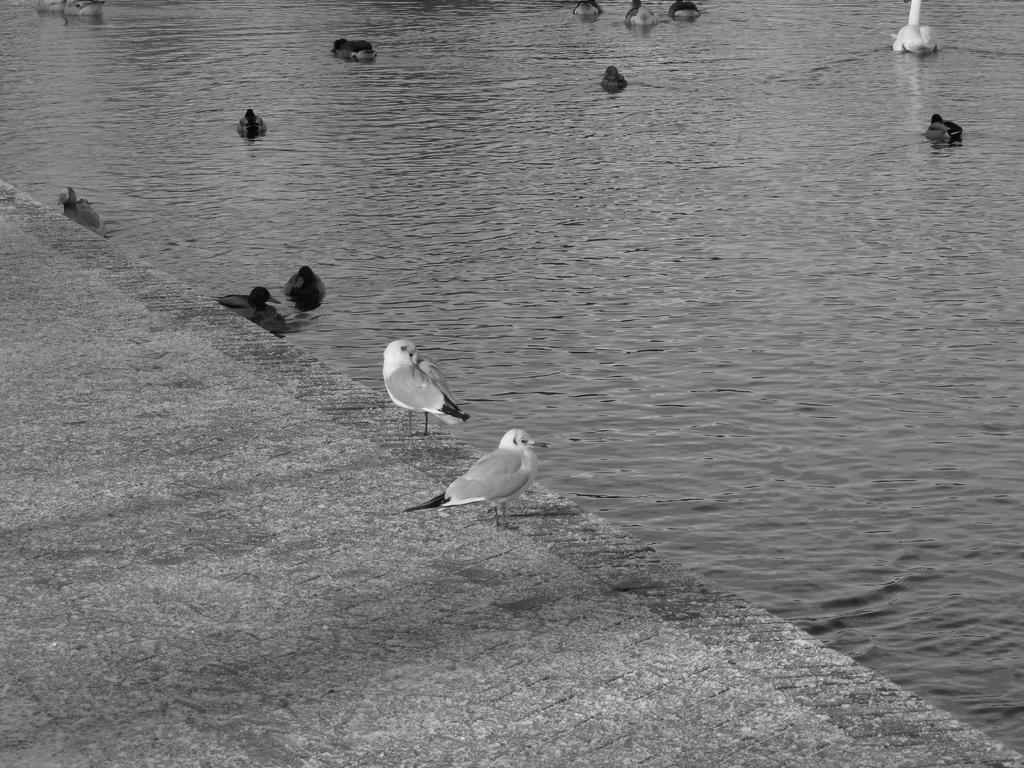Can you describe this image briefly? In this given image, We can see a water, few birds lying on a water after that, We can see two birds standing on a floor. 